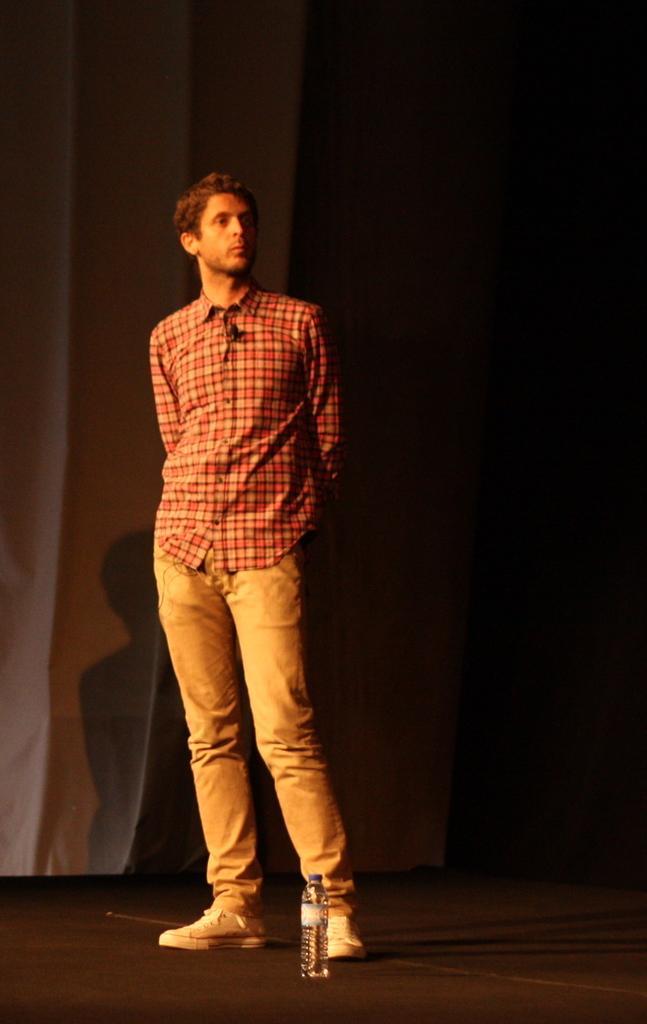Please provide a concise description of this image. As we can see in the image in the front there is a person wearing orange color shirt and bottle. On the left side there is a curtain. The image is little dark. 